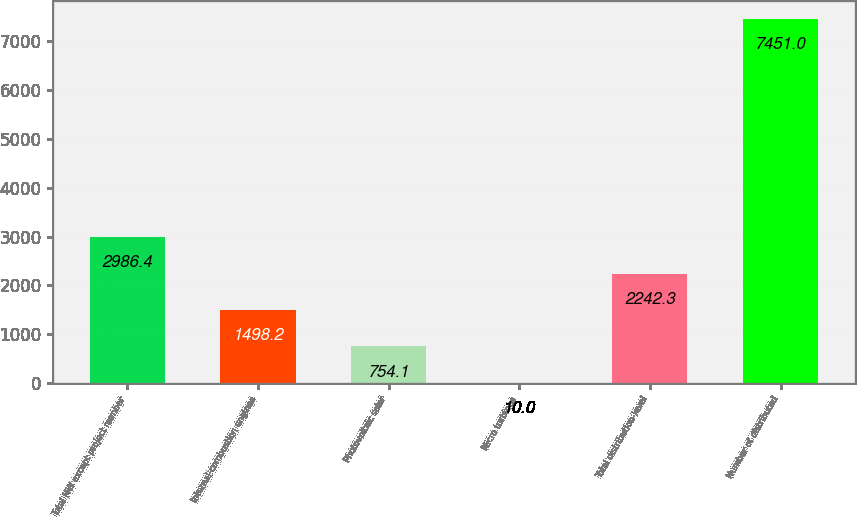Convert chart. <chart><loc_0><loc_0><loc_500><loc_500><bar_chart><fcel>Total MW except project number<fcel>Internal-combustion engines<fcel>Photovoltaic solar<fcel>Micro turbines<fcel>Total distribution-level<fcel>Number of distributed<nl><fcel>2986.4<fcel>1498.2<fcel>754.1<fcel>10<fcel>2242.3<fcel>7451<nl></chart> 